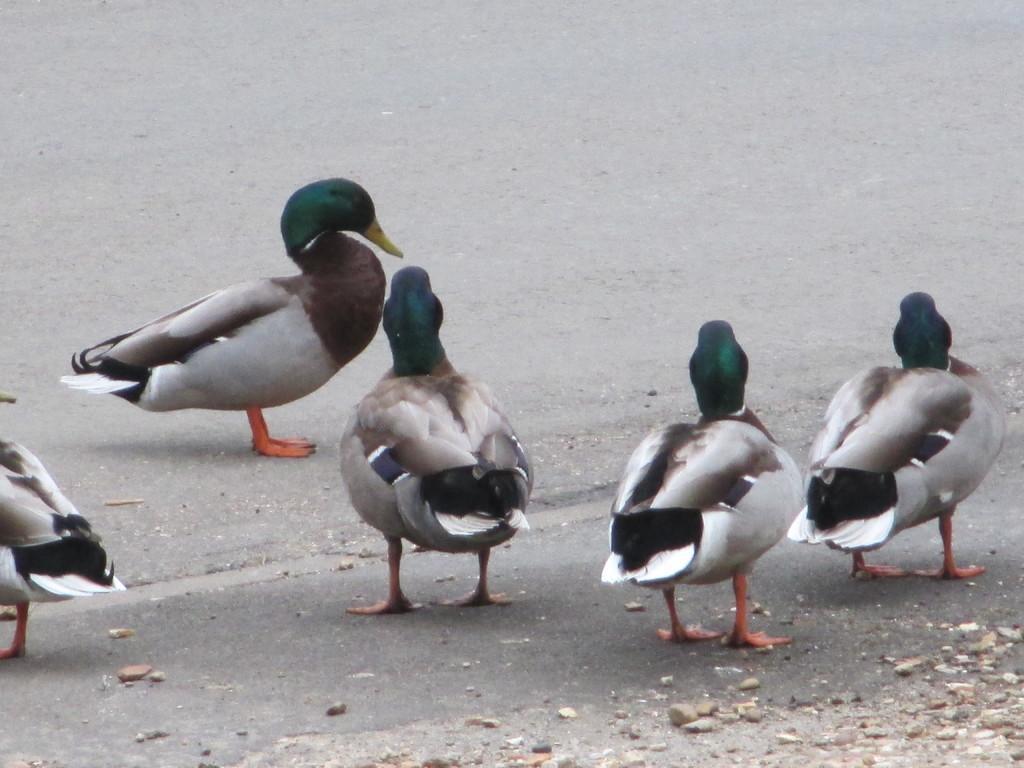Can you describe this image briefly? This picture shows few ducks on the road. They are white, black, brown and green in color. 